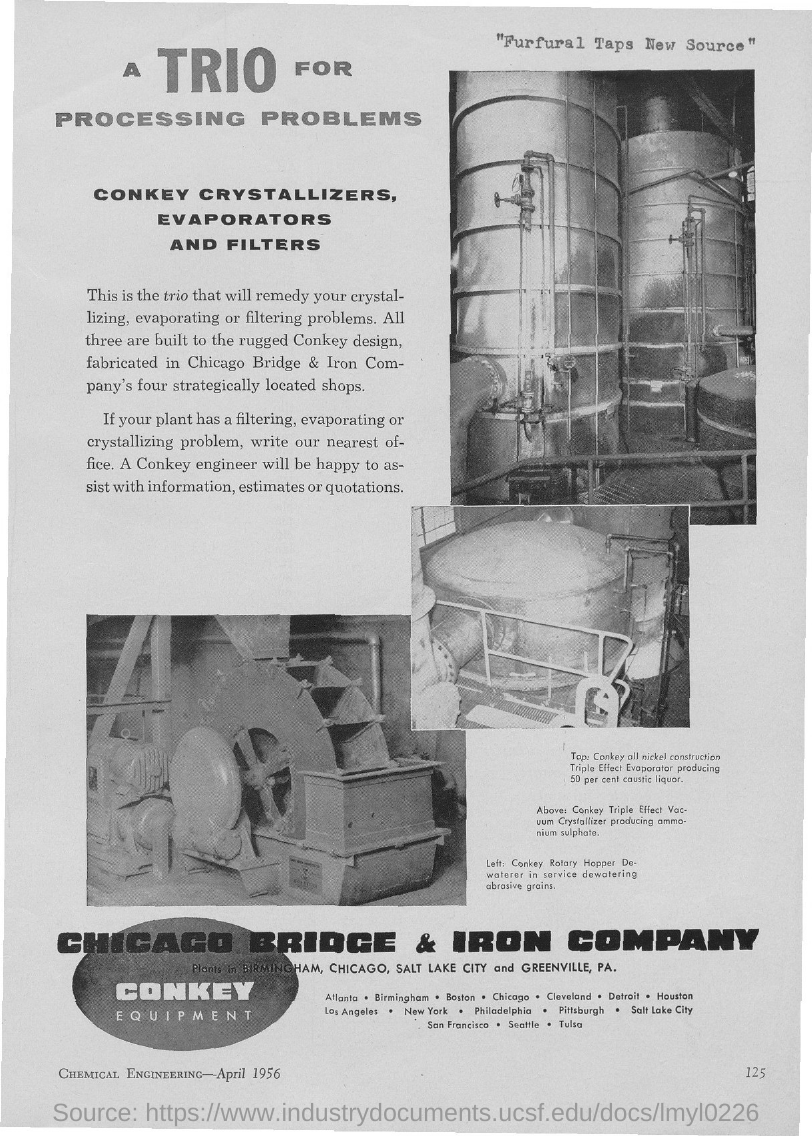Indicate a few pertinent items in this graphic. All three machines are built with the rugged Conkey design, which is specifically engineered to withstand heavy-duty use in various industries. The page number is 125. 